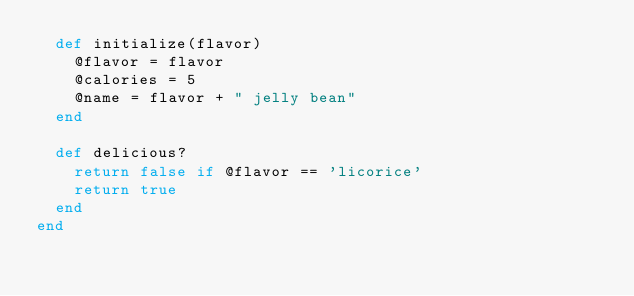Convert code to text. <code><loc_0><loc_0><loc_500><loc_500><_Ruby_>  def initialize(flavor)
    @flavor = flavor
    @calories = 5
    @name = flavor + " jelly bean"
  end

  def delicious?
    return false if @flavor == 'licorice'
    return true
  end
end
</code> 